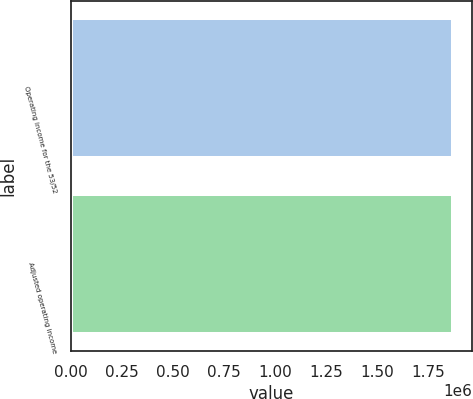<chart> <loc_0><loc_0><loc_500><loc_500><bar_chart><fcel>Operating income for the 53/52<fcel>Adjusted operating income<nl><fcel>1.87221e+06<fcel>1.87221e+06<nl></chart> 